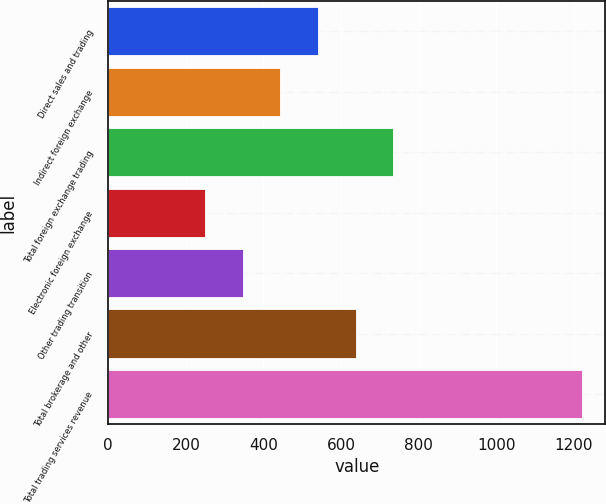<chart> <loc_0><loc_0><loc_500><loc_500><bar_chart><fcel>Direct sales and trading<fcel>Indirect foreign exchange<fcel>Total foreign exchange trading<fcel>Electronic foreign exchange<fcel>Other trading transition<fcel>Total brokerage and other<fcel>Total trading services revenue<nl><fcel>540.3<fcel>443.2<fcel>734.5<fcel>249<fcel>346.1<fcel>637.4<fcel>1220<nl></chart> 